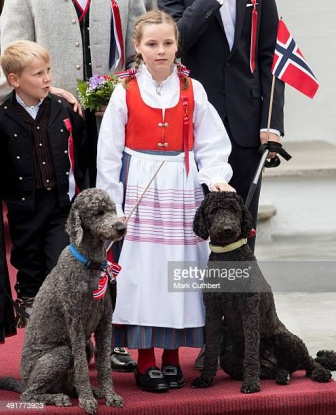Imagine if the poodles in the image were given royal titles for the day. What kind of responsibilities or ceremonies might they be involved in? If the poodles in the image were given royal titles for the day, they might participate in a whimsical ceremony. The gray poodle, now 'Duke of Paws,' could lead a parade of pets down the main street, showing off their elegant ribbons. Meanwhile, the black poodle, dubbed 'Lady Barkington,' could oversee a special 'Treat Banquet' where dogs of the realm gather to feast on gourmet dog treats. There might even be a spectacular dog agility show in their honor, where the Duke and Lady cheer for the contestants from a plush, royal viewing box. 